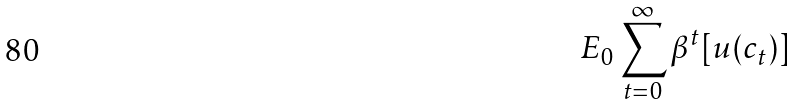Convert formula to latex. <formula><loc_0><loc_0><loc_500><loc_500>E _ { 0 } \sum _ { t = 0 } ^ { \infty } \beta ^ { t } [ u ( c _ { t } ) ]</formula> 